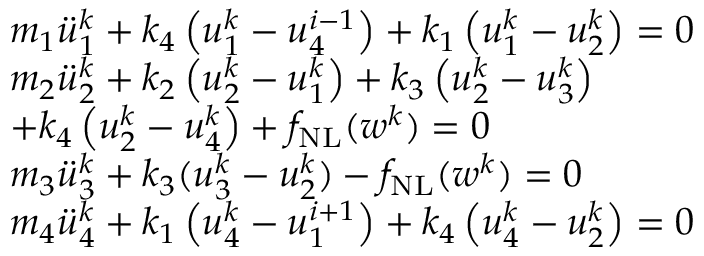<formula> <loc_0><loc_0><loc_500><loc_500>\begin{array} { r l } & { m _ { 1 } \ddot { u } _ { 1 } ^ { k } + k _ { 4 } \left ( u _ { 1 } ^ { k } - u _ { 4 } ^ { i - 1 } \right ) + k _ { 1 } \left ( u _ { 1 } ^ { k } - u _ { 2 } ^ { k } \right ) = 0 } \\ & { m _ { 2 } \ddot { u } _ { 2 } ^ { k } + k _ { 2 } \left ( u _ { 2 } ^ { k } - u _ { 1 } ^ { k } \right ) + k _ { 3 } \left ( u _ { 2 } ^ { k } - u _ { 3 } ^ { k } \right ) } \\ & { + k _ { 4 } \left ( u _ { 2 } ^ { k } - u _ { 4 } ^ { k } \right ) + f _ { N L } ( w ^ { k } ) = 0 } \\ & { m _ { 3 } \ddot { u } _ { 3 } ^ { k } + k _ { 3 } ( u _ { 3 } ^ { k } - u _ { 2 } ^ { k } ) - f _ { N L } ( w ^ { k } ) = 0 } \\ & { m _ { 4 } \ddot { u } _ { 4 } ^ { k } + k _ { 1 } \left ( u _ { 4 } ^ { k } - u _ { 1 } ^ { i + 1 } \right ) + k _ { 4 } \left ( u _ { 4 } ^ { k } - u _ { 2 } ^ { k } \right ) = 0 } \end{array}</formula> 